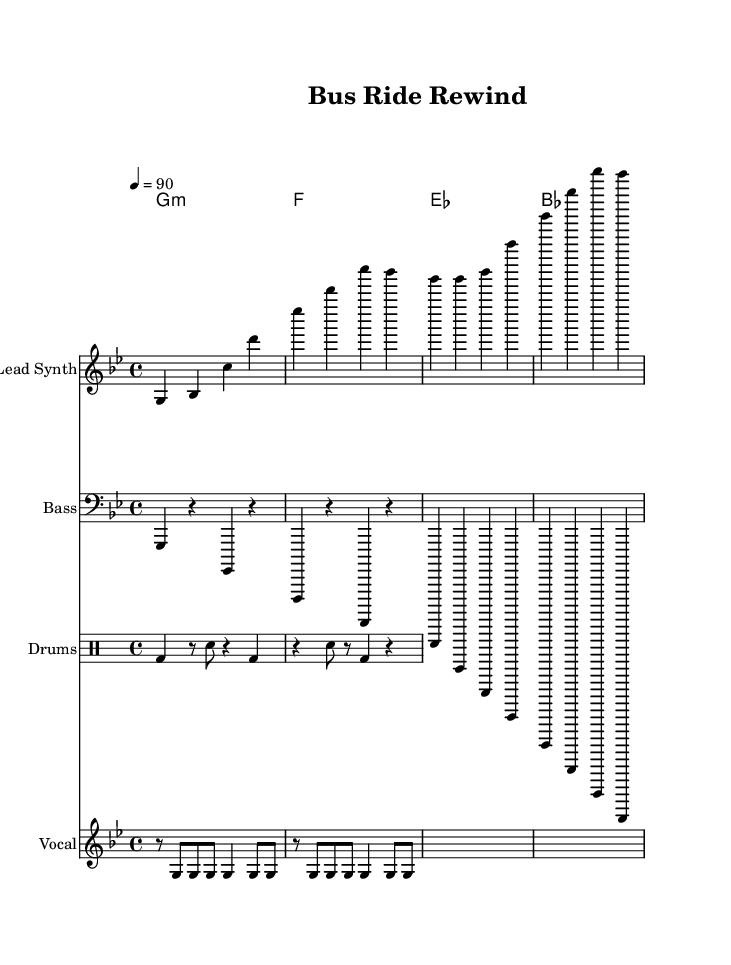What is the key signature of this music? The key signature is G minor, indicated by the one flat in the key context.
Answer: G minor What is the time signature of this music? The time signature is 4/4, which is indicated in the header section of the score.
Answer: 4/4 What is the tempo marking of this music? The tempo marking is quarter note equals 90, specified in the tempo instruction at the top.
Answer: 90 What instruments are featured in the score? The score features Lead Synth, Bass, Drums, and Vocal parts, as indicated by the staff labels.
Answer: Lead Synth, Bass, Drums, Vocal In which section do the lyrics appear? The lyrics appear in the Vocal staff, underneath the vocal rhythm part, specifically aligned with the musical notes.
Answer: Vocal How many beats are in each measure for the verse? Each measure has four beats in the verse section, as indicated by the 4/4 time signature.
Answer: Four beats What mood does the music convey based on its tempo and structure? The music conveys a laid-back and nostalgic mood, typical for a 90s rap vibe, which is reinforced by its slow tempo and simple rhythmic patterns.
Answer: Laid-back and nostalgic mood 